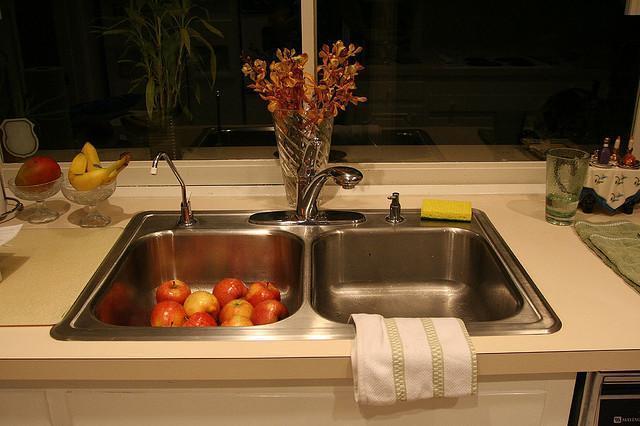How many apples are in the sink?
Give a very brief answer. 9. How many sinks are there?
Give a very brief answer. 2. How many trains are in the photo?
Give a very brief answer. 0. 